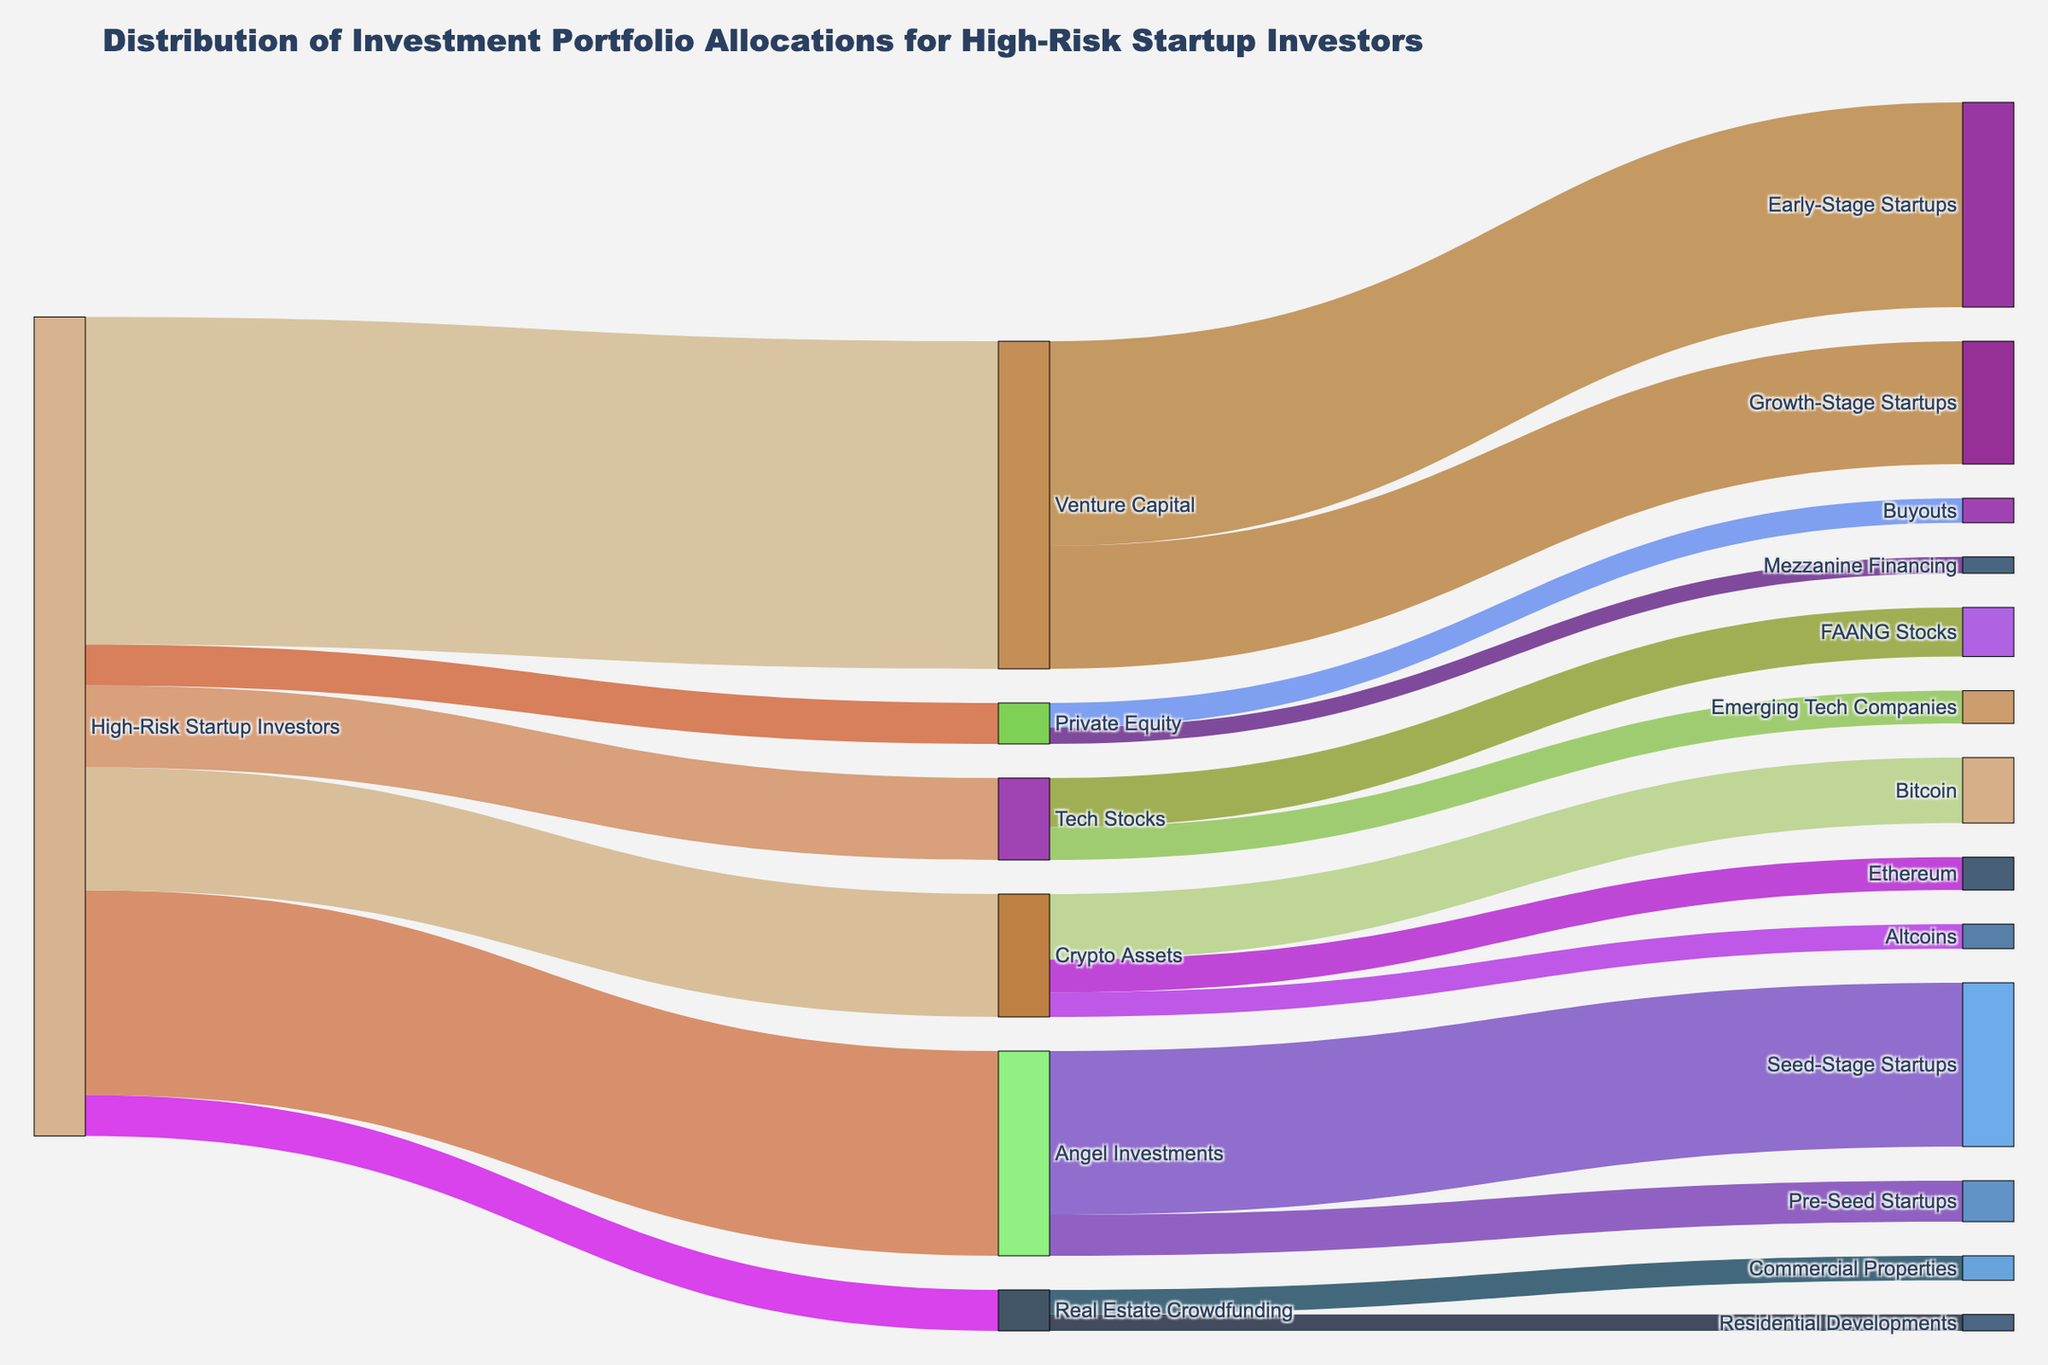what is the main title of the diagram? The title is usually located at the top of the figure. In this Sankey Diagram, the title is prominently displayed.
Answer: Distribution of Investment Portfolio Allocations for High-Risk Startup Investors what percentage of investments in high-risk startup portfolios goes into venture capital? The diagram shows allocation percentages split into various categories. The link from 'High-Risk Startup Investors' to 'Venture Capital' indicates the percentage allocated.
Answer: 40% How does the investment in tech stocks compare to angel investments? Look at the links from 'High-Risk Startup Investors' to both 'Tech Stocks' and 'Angel Investments.' Compare the numerical values shown.
Answer: Tech Stocks: 10%, Angel Investments: 25% What categories are included under angel investments? Find the links that stem from 'Angel Investments' to understand its subcategories listed in the diagram.
Answer: Seed-Stage Startups, Pre-Seed Startups What is the combined percentage of investments allocated to private equity and real estate crowdfunding? Find the percentages allocated to 'Private Equity' and 'Real Estate Crowdfunding.' Add these values together.
Answer: 5% (Private Equity) + 5% (Real Estate Crowdfunding) = 10% Which tech stock category gets a smaller investment, FAANG stocks or emerging tech companies? Check the links stemming from 'Tech Stocks' to 'FAANG Stocks' and 'Emerging Tech Companies' to compare their respective values.
Answer: Emerging Tech Companies What portion of crypto asset investments is assigned to Bitcoin? Observe the link going from 'Crypto Assets' to 'Bitcoin' in the diagram to find this percentage.
Answer: 8% Is the investment in early-stage startups higher than that in growth-stage startups for venture capital? By examining the links from 'Venture Capital' to 'Early-Stage Startups' and 'Growth-Stage Startups,' compare the figures displayed.
Answer: Yes, Early-Stage Startups (25%) is higher than Growth-Stage Startups (15%) Among the subcategories of angel investments, which one has the least allocation? Identify and compare the values shown for the subcategories under 'Angel Investments.'
Answer: Pre-Seed Startups 